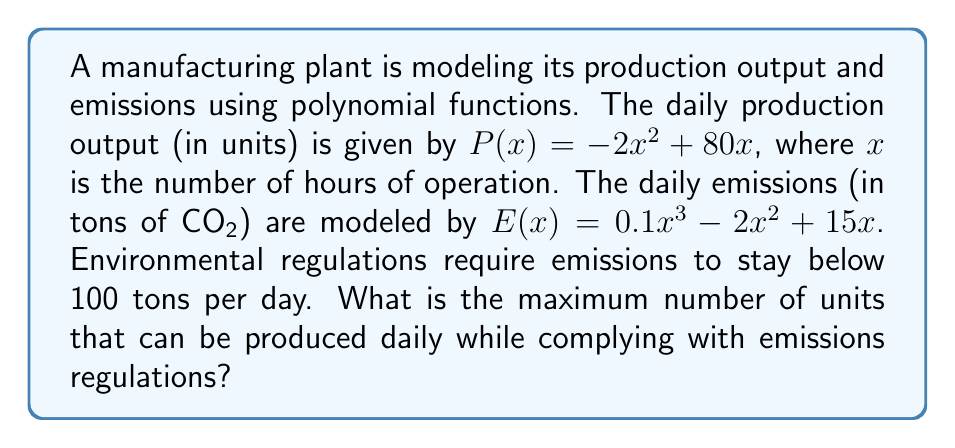Provide a solution to this math problem. To solve this problem, we need to follow these steps:

1. Find the domain of $x$ that satisfies the emissions constraint.
2. Within this domain, find the maximum of the production function.

Step 1: Emissions constraint

The emissions function is $E(x) = 0.1x^3 - 2x^2 + 15x$. We need to solve:

$$0.1x^3 - 2x^2 + 15x \leq 100$$

This is a complex inequality. We can solve it graphically or numerically. Using a graphing calculator or computer algebra system, we find that the solution is approximately:

$$0 \leq x \leq 11.62$$

Step 2: Maximizing production

The production function is $P(x) = -2x^2 + 80x$. To find its maximum within the domain $[0, 11.62]$, we can:

a) Find the vertex of the parabola:
   $$x = -\frac{b}{2a} = -\frac{80}{2(-2)} = 20$$

   However, this is outside our domain.

b) Therefore, the maximum must occur at one of the endpoints of our domain.

Evaluating $P(x)$ at the endpoints:
   $P(0) = 0$
   $P(11.62) \approx -2(11.62)^2 + 80(11.62) = 674.45$

The maximum production occurs at $x \approx 11.62$ hours.
Answer: The maximum daily production while complying with emissions regulations is approximately 674 units. 